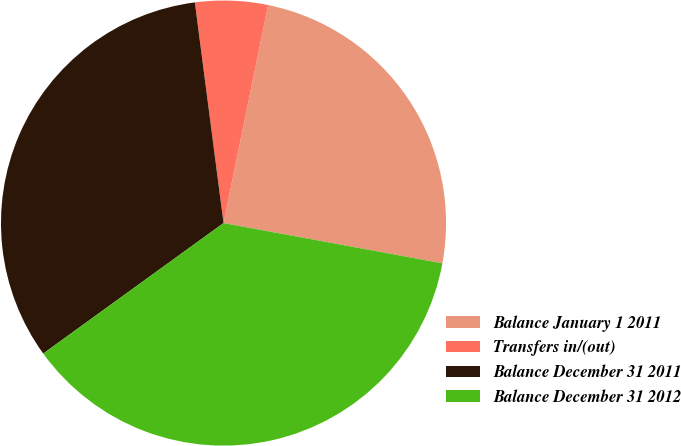Convert chart. <chart><loc_0><loc_0><loc_500><loc_500><pie_chart><fcel>Balance January 1 2011<fcel>Transfers in/(out)<fcel>Balance December 31 2011<fcel>Balance December 31 2012<nl><fcel>24.68%<fcel>5.27%<fcel>32.91%<fcel>37.13%<nl></chart> 